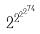Convert formula to latex. <formula><loc_0><loc_0><loc_500><loc_500>2 ^ { 2 ^ { 2 ^ { 2 ^ { 7 4 } } } }</formula> 